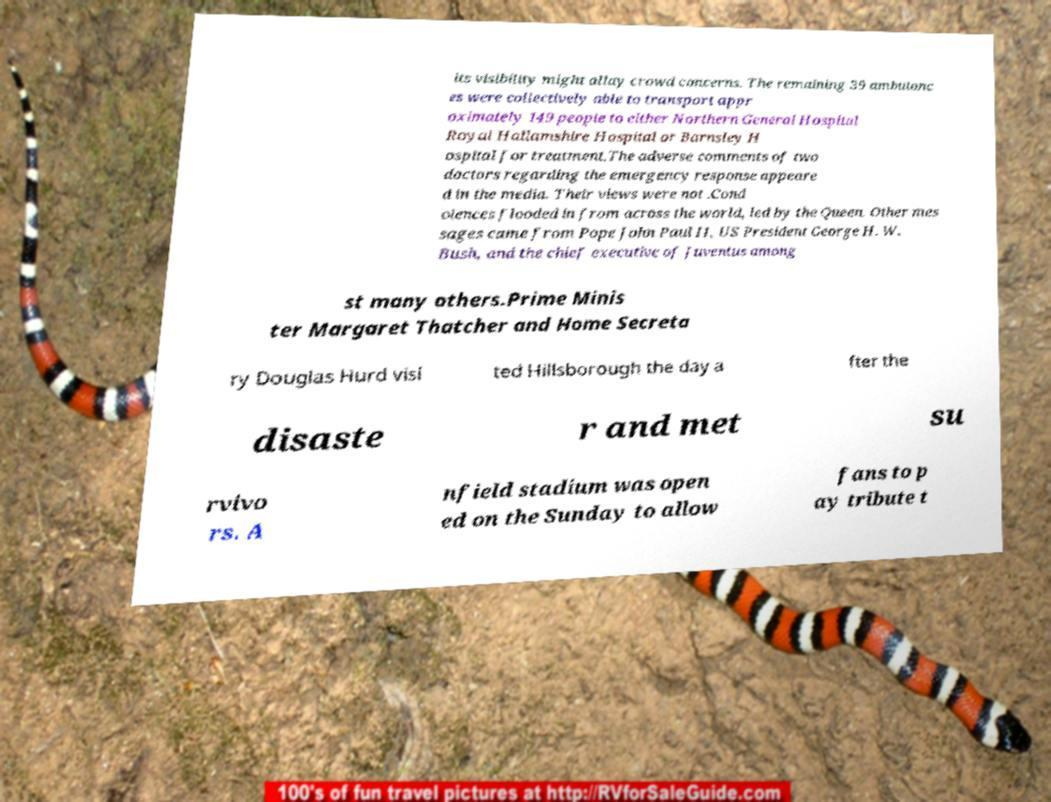For documentation purposes, I need the text within this image transcribed. Could you provide that? its visibility might allay crowd concerns. The remaining 39 ambulanc es were collectively able to transport appr oximately 149 people to either Northern General Hospital Royal Hallamshire Hospital or Barnsley H ospital for treatment.The adverse comments of two doctors regarding the emergency response appeare d in the media. Their views were not .Cond olences flooded in from across the world, led by the Queen. Other mes sages came from Pope John Paul II, US President George H. W. Bush, and the chief executive of Juventus among st many others.Prime Minis ter Margaret Thatcher and Home Secreta ry Douglas Hurd visi ted Hillsborough the day a fter the disaste r and met su rvivo rs. A nfield stadium was open ed on the Sunday to allow fans to p ay tribute t 